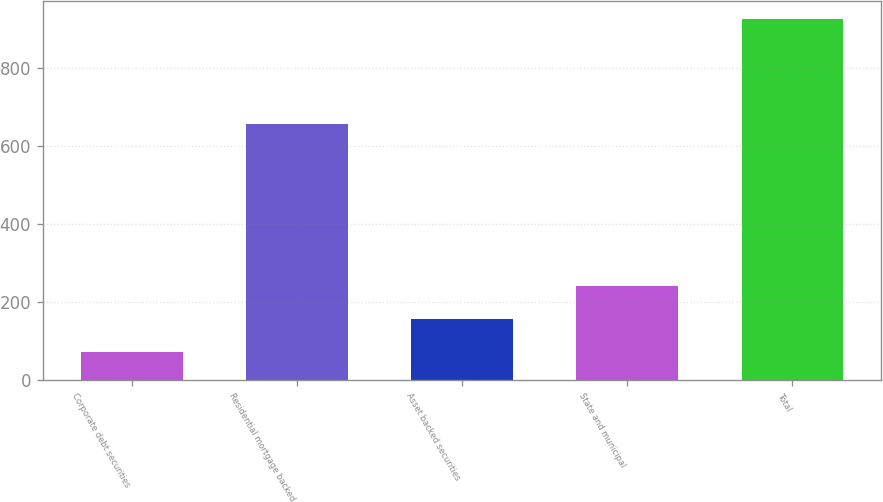Convert chart. <chart><loc_0><loc_0><loc_500><loc_500><bar_chart><fcel>Corporate debt securities<fcel>Residential mortgage backed<fcel>Asset backed securities<fcel>State and municipal<fcel>Total<nl><fcel>70<fcel>658<fcel>155.7<fcel>241.4<fcel>927<nl></chart> 